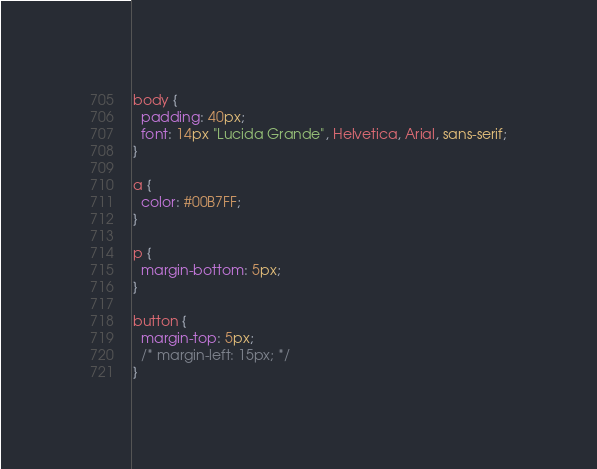Convert code to text. <code><loc_0><loc_0><loc_500><loc_500><_CSS_>body {
  padding: 40px;
  font: 14px "Lucida Grande", Helvetica, Arial, sans-serif;
}

a {
  color: #00B7FF;
}

p {
  margin-bottom: 5px;
}

button {
  margin-top: 5px;
  /* margin-left: 15px; */
}</code> 